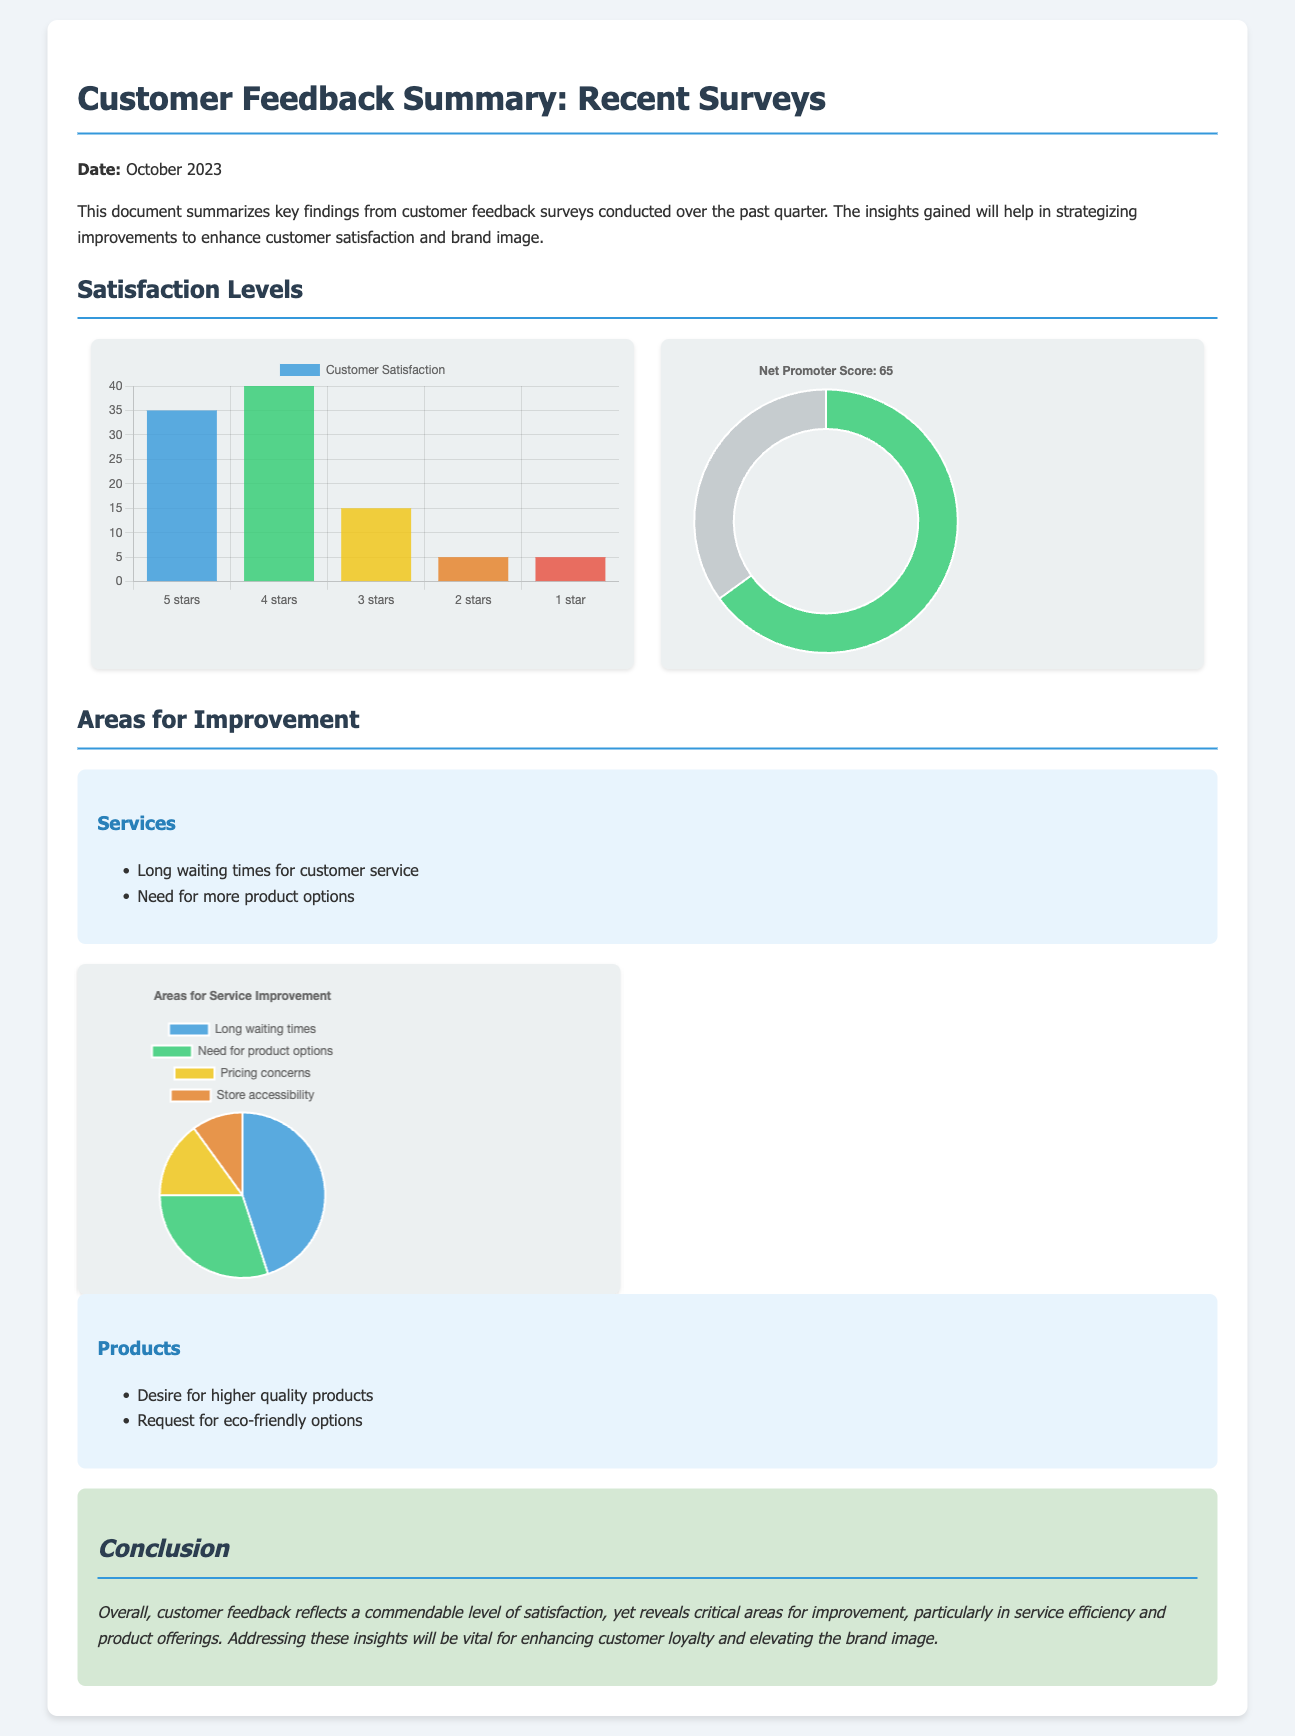What is the date of the document? The document is dated October 2023, as indicated at the top.
Answer: October 2023 What is the Net Promoter Score? The NPS score is shown in the doughnut chart with a value of 65.
Answer: 65 What percentage of customers rated satisfaction as five stars? The satisfaction chart shows that 35% of customers rated satisfaction as five stars.
Answer: 35% What are two areas identified for service improvement? The document lists "Long waiting times for customer service" and "Need for more product options" under areas for service improvement.
Answer: Long waiting times, Need for more product options What chart type is used to represent the areas for service improvement? The areas for service improvement are represented in a pie chart format, as indicated in the document.
Answer: Pie chart How many customers rated satisfaction as three stars? The satisfaction chart shows that 15% rated satisfaction as three stars.
Answer: 15% What is the primary focus of the conclusion? The conclusion summarizes customer satisfaction and identifies critical areas for improvement in service efficiency and product offerings.
Answer: Customer satisfaction and improvements What is one desire mentioned for product improvement? The document notes a "Desire for higher quality products" as a customer feedback point for improvement.
Answer: Higher quality products 